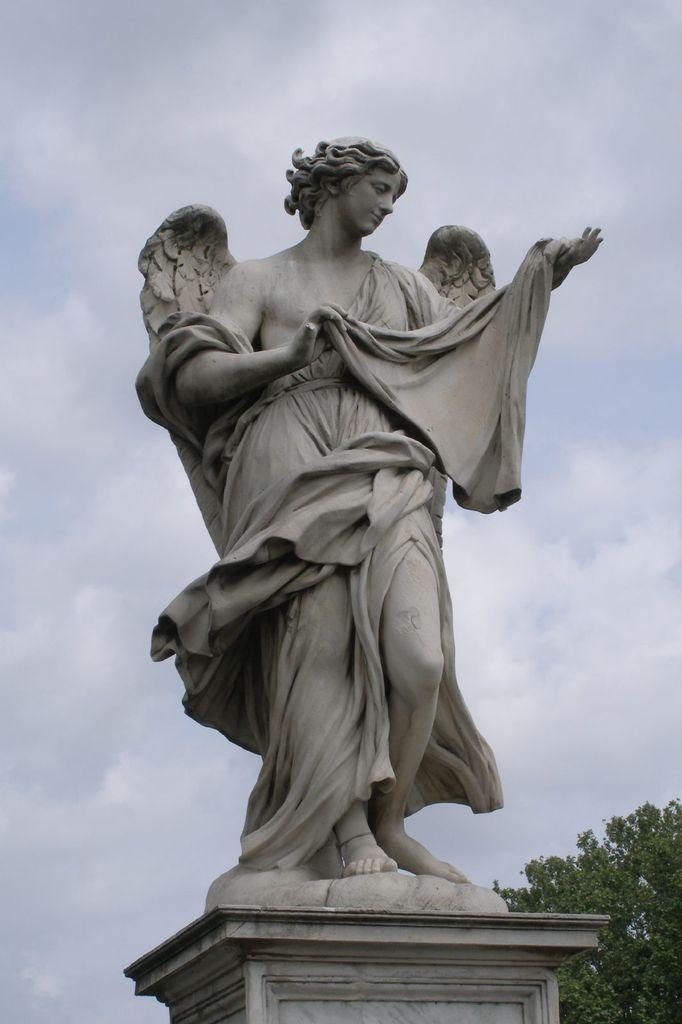What is the main subject in the image? There is a statue of a woman in the image. What is the color of the statue? The statue is in grey color. What can be seen in the background of the image? There is a tree and the sky in the background of the image. What is visible in the sky? There are clouds visible in the sky. What type of advertisement can be seen on the statue? There is no advertisement present on the statue in the image. --- Facts: 1. There is a person in the image. 2. The person is wearing a hat. 3. The person is holding a book. 4. There is a wooden bench in the image. 5. The background of the image is a park. Absurd Topics: dinosaur, parachute, ocean Conversation: What is the person in the image doing? The person in the image is holding a book. What is the person in the image wearing? The person in the image is wearing a hat. What object is present in the image? There is a wooden bench in the image. What can be seen in the background of the image? The background of the image is a park. Reasoning: Let's think step by step in order to produce the conversation. We start by identifying the main subject of the image, which is the person. Next, we describe the specific features of the person, such as the hat they are wearing. Then, we observe the actions of the person in the image, noting that they are holding a book. After that, we identify the object present in the image, which is a wooden bench. Finally, we describe the background of the image, noting that it is a park. Absurd Question/Answer: Can a dinosaur be seen in the image? No, a dinosaur cannot be seen in the image. --- Facts: 1. There is a cat in the image. 2. The cat is sitting on a windowsill. 3. The windowsill is located near a window. 4. The window has curtains. 5. The background of the image is a cityscape. Absurd Topics: elephant, trampoline, forest Conversation: What type of animal is in the image? There is a cat in the image. Where is the cat located in the image? The cat is sitting on a windowsill. What is located near the windowsill? The windowsill is located near a window. What can be seen on the window in the image? The window has curtains. What can be seen in the background of the image? The background of the image is a cityscape. Reasoning: Let's think step by step in order to produce the conversation. 